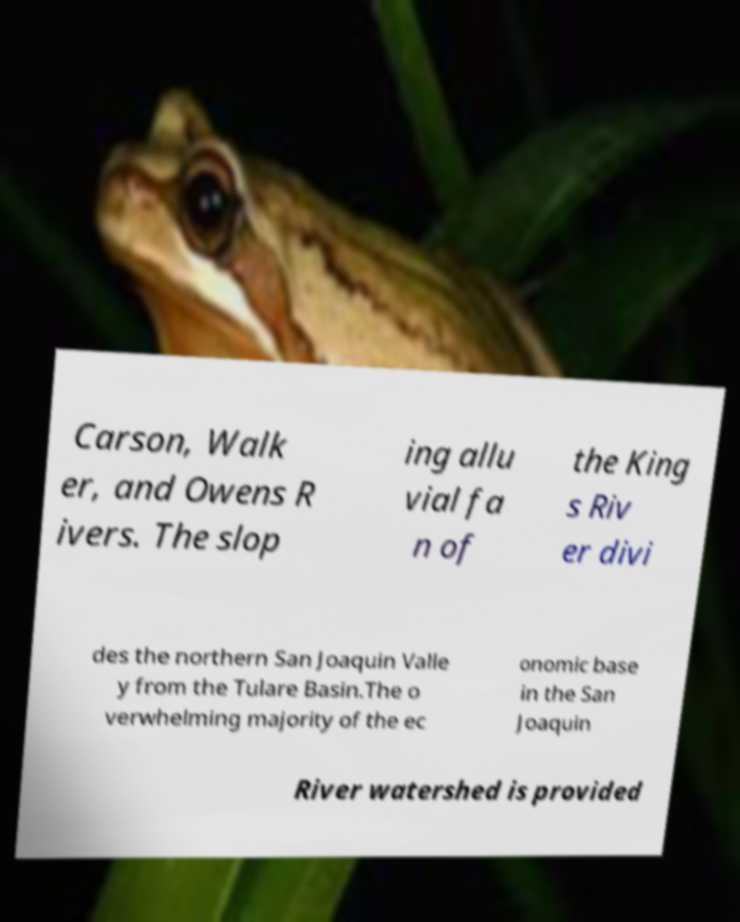I need the written content from this picture converted into text. Can you do that? Carson, Walk er, and Owens R ivers. The slop ing allu vial fa n of the King s Riv er divi des the northern San Joaquin Valle y from the Tulare Basin.The o verwhelming majority of the ec onomic base in the San Joaquin River watershed is provided 